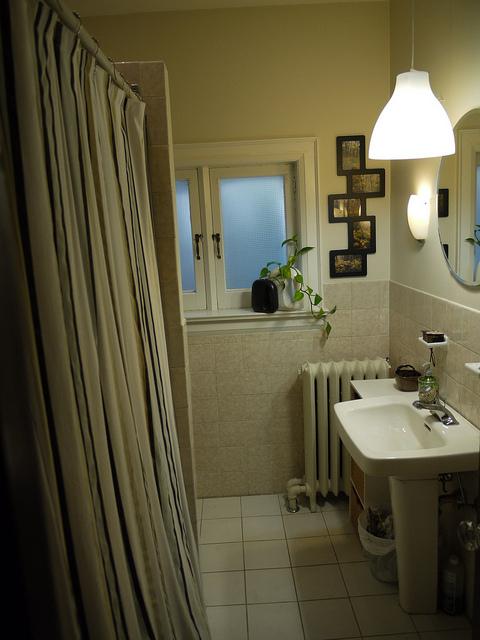What kind of window treatments are shown?
Concise answer only. None. What is hanging from the wall?
Short answer required. Light. What is on the wall above the lamp?
Give a very brief answer. Mirror. Is it daytime?
Give a very brief answer. Yes. What room is this in the house?
Concise answer only. Bathroom. Is this a fancy bathroom?
Give a very brief answer. No. How many lights are over the sink?
Quick response, please. 2. Is it sunny day?
Be succinct. No. Are the doors open?
Quick response, please. No. What's the thing in the corner?
Be succinct. Radiator. Do the sinks match the bathtub?
Concise answer only. Yes. Is the floor a solid color?
Concise answer only. No. What color are the wall tiles?
Short answer required. Tan. What is next to the sink?
Short answer required. Cabinet. What is the plant sitting on?
Quick response, please. Window sill. 